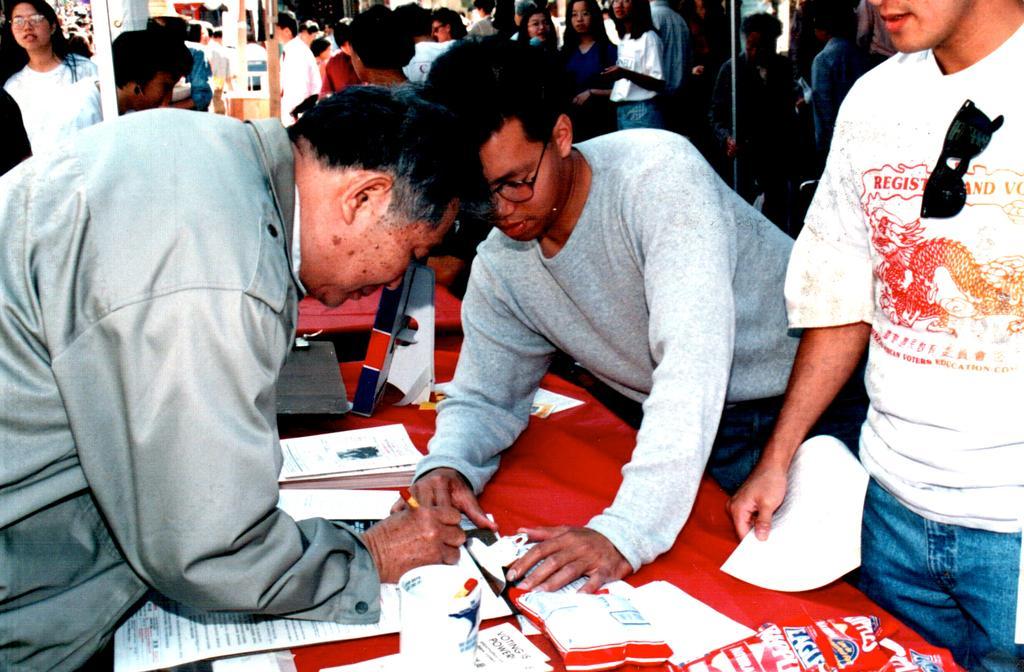How would you summarize this image in a sentence or two? As we can see in the image there are group of people and in the front there is a table. On table there is are papers, glass and red color cloth. 